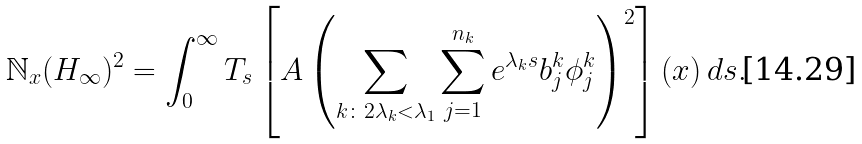<formula> <loc_0><loc_0><loc_500><loc_500>\mathbb { N } _ { x } ( H _ { \infty } ) ^ { 2 } = \int _ { 0 } ^ { \infty } T _ { s } \left [ A \left ( \sum _ { k \colon 2 \lambda _ { k } < \lambda _ { 1 } } \sum _ { j = 1 } ^ { n _ { k } } e ^ { \lambda _ { k } s } b _ { j } ^ { k } \phi _ { j } ^ { k } \right ) ^ { 2 } \right ] ( x ) \, d s .</formula> 